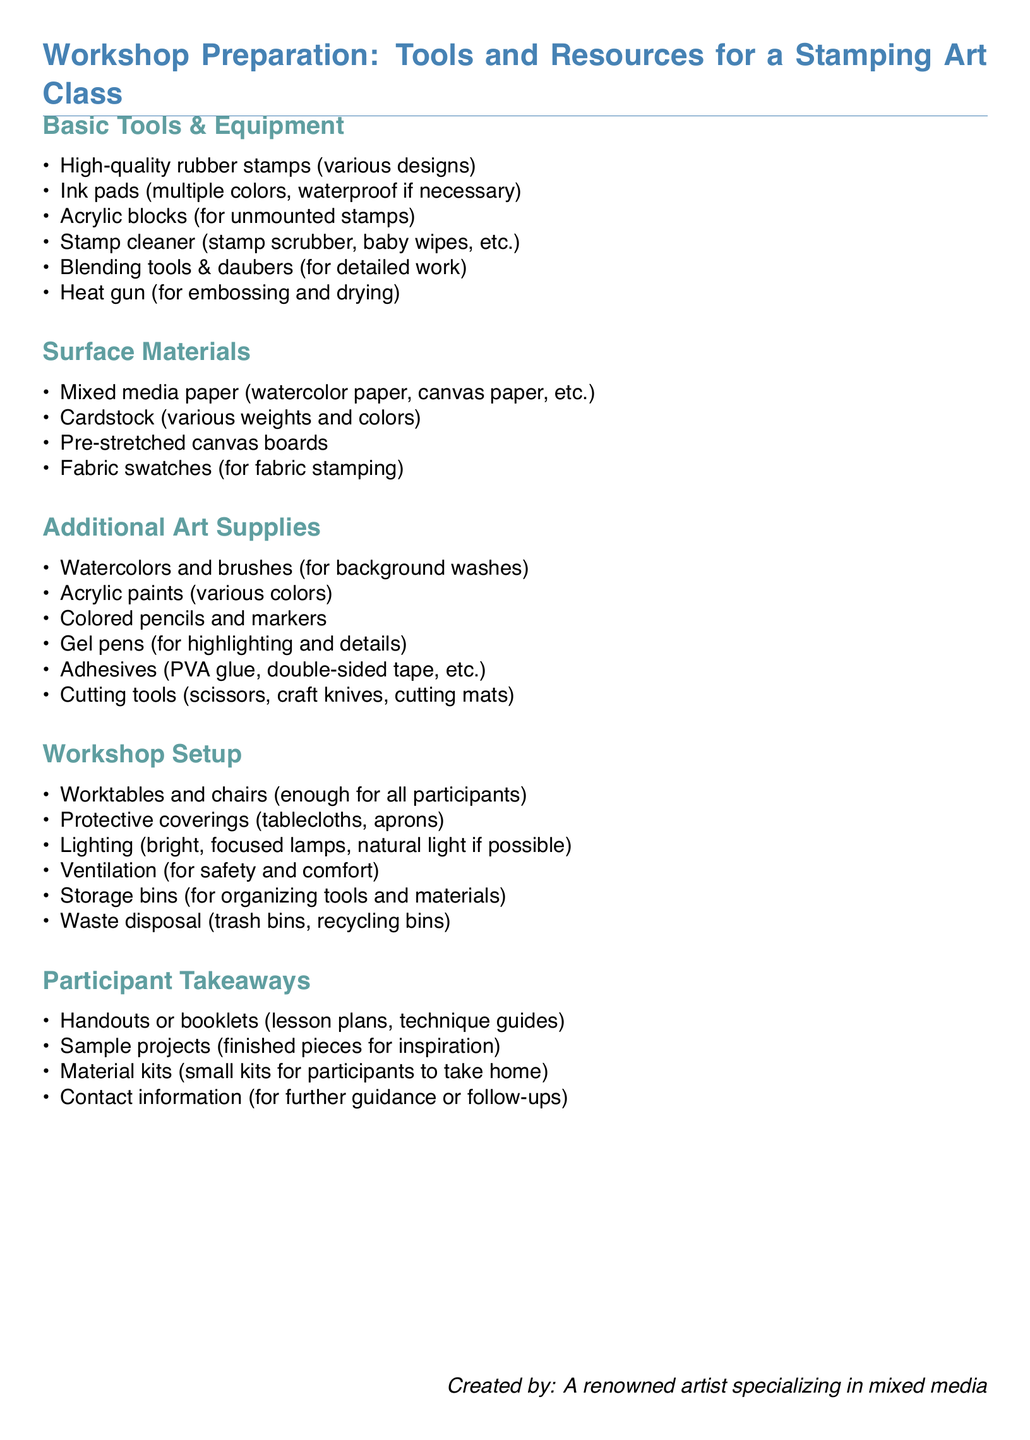What are the basic tools listed? The document lists high-quality rubber stamps, ink pads, acrylic blocks, stamp cleaner, blending tools, and a heat gun under basic tools.
Answer: High-quality rubber stamps, ink pads, acrylic blocks, stamp cleaner, blending tools, heat gun How many categories are there in the checklist? The checklist contains five main categories: Basic Tools & Equipment, Surface Materials, Additional Art Supplies, Workshop Setup, and Participant Takeaways.
Answer: Five What type of paper is suggested for stamping? The document specifies mixed media paper and cardstock as suitable types of paper for stamping activities.
Answer: Mixed media paper, cardstock What is included in the participant takeaways? The takeaways include handouts, sample projects, material kits, and contact information for further guidance.
Answer: Handouts, sample projects, material kits, contact information What lighting condition is recommended for the workshop? The document suggests using bright, focused lamps and natural light if possible for the optimal workshop environment.
Answer: Bright, focused lamps, natural light What type of coverage is suggested for worktables? Protective coverings such as tablecloths and aprons are recommended to protect the workspace during the workshop.
Answer: Tablecloths, aprons How many types of adhesives are mentioned? The document lists various types of adhesives, specifically mentioning PVA glue and double-sided tape without providing an exact count.
Answer: Two types 